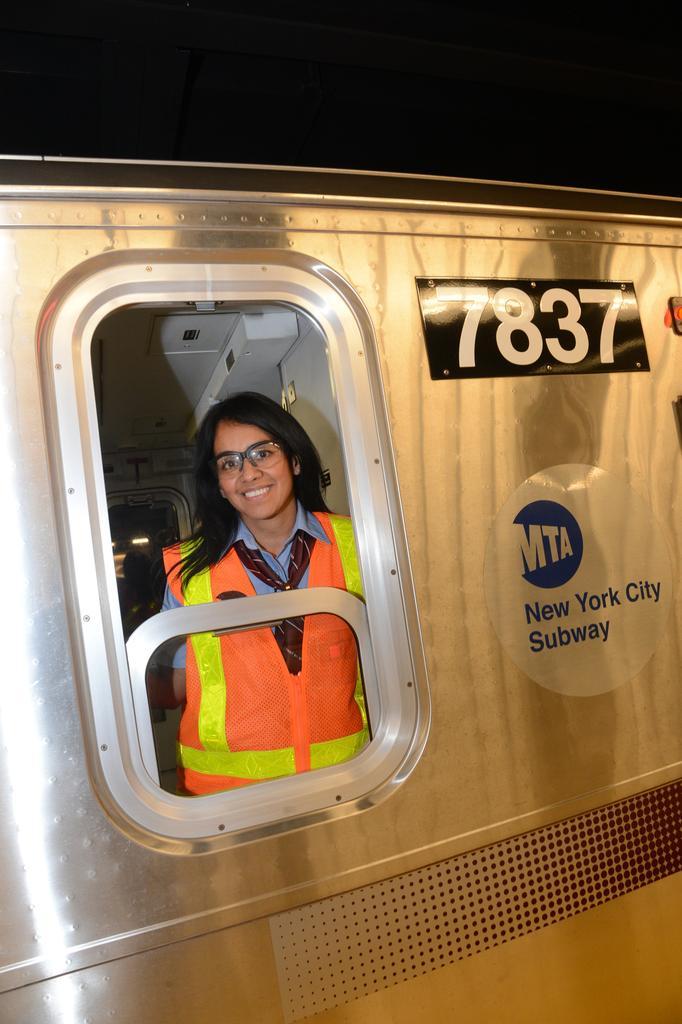Please provide a concise description of this image. This picture shows a subway train and we see a woman from the window. She wore spectacles on her face and a coat. 